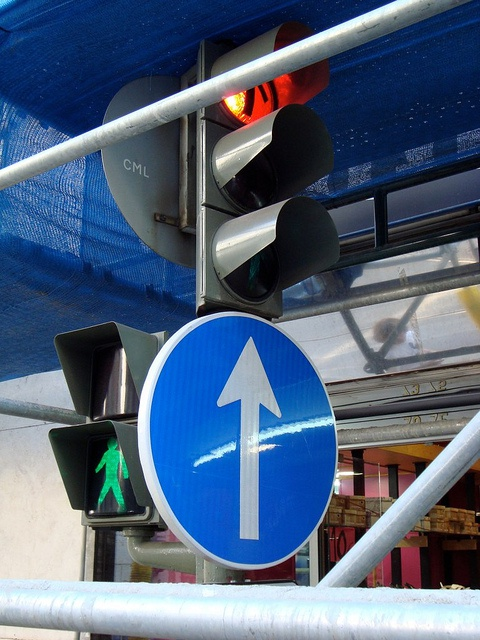Describe the objects in this image and their specific colors. I can see traffic light in lightblue, black, gray, darkgray, and navy tones, traffic light in lightblue, black, gray, and ivory tones, and traffic light in lightblue, black, green, gray, and lightgreen tones in this image. 